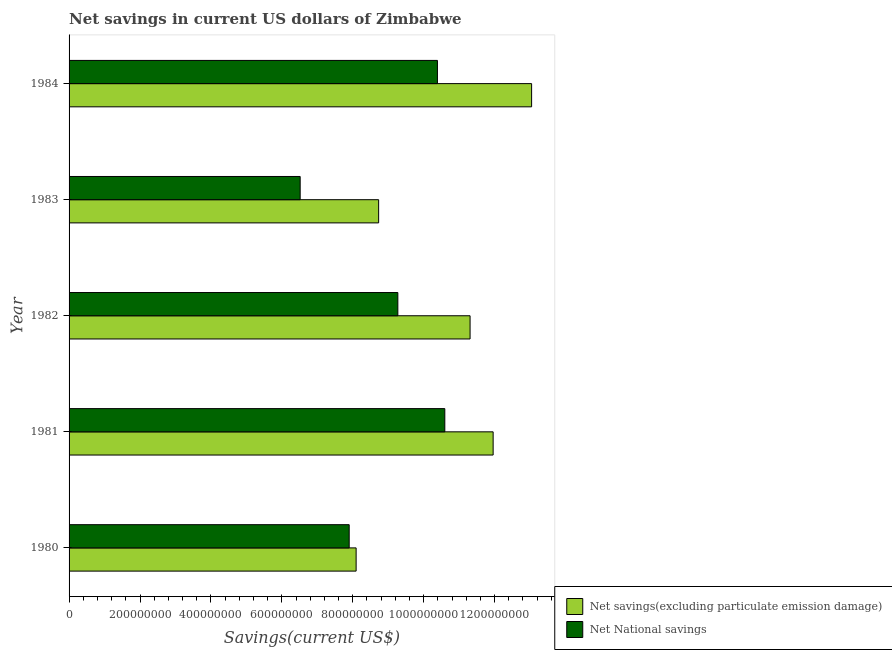How many different coloured bars are there?
Make the answer very short. 2. Are the number of bars per tick equal to the number of legend labels?
Your response must be concise. Yes. Are the number of bars on each tick of the Y-axis equal?
Make the answer very short. Yes. How many bars are there on the 4th tick from the top?
Your answer should be compact. 2. What is the label of the 1st group of bars from the top?
Offer a very short reply. 1984. In how many cases, is the number of bars for a given year not equal to the number of legend labels?
Provide a short and direct response. 0. What is the net savings(excluding particulate emission damage) in 1984?
Ensure brevity in your answer.  1.30e+09. Across all years, what is the maximum net savings(excluding particulate emission damage)?
Offer a terse response. 1.30e+09. Across all years, what is the minimum net savings(excluding particulate emission damage)?
Your answer should be very brief. 8.09e+08. In which year was the net savings(excluding particulate emission damage) maximum?
Keep it short and to the point. 1984. In which year was the net savings(excluding particulate emission damage) minimum?
Your answer should be very brief. 1980. What is the total net national savings in the graph?
Your answer should be compact. 4.47e+09. What is the difference between the net national savings in 1981 and that in 1982?
Keep it short and to the point. 1.32e+08. What is the difference between the net savings(excluding particulate emission damage) in 1984 and the net national savings in 1983?
Your response must be concise. 6.53e+08. What is the average net savings(excluding particulate emission damage) per year?
Provide a short and direct response. 1.06e+09. In the year 1980, what is the difference between the net national savings and net savings(excluding particulate emission damage)?
Keep it short and to the point. -1.95e+07. What is the ratio of the net savings(excluding particulate emission damage) in 1980 to that in 1982?
Provide a short and direct response. 0.72. Is the net savings(excluding particulate emission damage) in 1980 less than that in 1982?
Give a very brief answer. Yes. Is the difference between the net savings(excluding particulate emission damage) in 1982 and 1983 greater than the difference between the net national savings in 1982 and 1983?
Offer a very short reply. No. What is the difference between the highest and the second highest net national savings?
Provide a short and direct response. 2.08e+07. What is the difference between the highest and the lowest net savings(excluding particulate emission damage)?
Give a very brief answer. 4.95e+08. In how many years, is the net savings(excluding particulate emission damage) greater than the average net savings(excluding particulate emission damage) taken over all years?
Your answer should be very brief. 3. Is the sum of the net savings(excluding particulate emission damage) in 1981 and 1983 greater than the maximum net national savings across all years?
Make the answer very short. Yes. What does the 1st bar from the top in 1984 represents?
Offer a terse response. Net National savings. What does the 2nd bar from the bottom in 1982 represents?
Your answer should be compact. Net National savings. Are all the bars in the graph horizontal?
Give a very brief answer. Yes. What is the difference between two consecutive major ticks on the X-axis?
Give a very brief answer. 2.00e+08. Where does the legend appear in the graph?
Your answer should be very brief. Bottom right. How many legend labels are there?
Give a very brief answer. 2. What is the title of the graph?
Offer a very short reply. Net savings in current US dollars of Zimbabwe. What is the label or title of the X-axis?
Your answer should be compact. Savings(current US$). What is the Savings(current US$) in Net savings(excluding particulate emission damage) in 1980?
Give a very brief answer. 8.09e+08. What is the Savings(current US$) in Net National savings in 1980?
Offer a very short reply. 7.90e+08. What is the Savings(current US$) of Net savings(excluding particulate emission damage) in 1981?
Provide a short and direct response. 1.20e+09. What is the Savings(current US$) in Net National savings in 1981?
Your answer should be very brief. 1.06e+09. What is the Savings(current US$) of Net savings(excluding particulate emission damage) in 1982?
Provide a short and direct response. 1.13e+09. What is the Savings(current US$) in Net National savings in 1982?
Keep it short and to the point. 9.27e+08. What is the Savings(current US$) in Net savings(excluding particulate emission damage) in 1983?
Your response must be concise. 8.73e+08. What is the Savings(current US$) of Net National savings in 1983?
Your answer should be very brief. 6.52e+08. What is the Savings(current US$) in Net savings(excluding particulate emission damage) in 1984?
Give a very brief answer. 1.30e+09. What is the Savings(current US$) in Net National savings in 1984?
Provide a succinct answer. 1.04e+09. Across all years, what is the maximum Savings(current US$) of Net savings(excluding particulate emission damage)?
Make the answer very short. 1.30e+09. Across all years, what is the maximum Savings(current US$) of Net National savings?
Make the answer very short. 1.06e+09. Across all years, what is the minimum Savings(current US$) in Net savings(excluding particulate emission damage)?
Your answer should be very brief. 8.09e+08. Across all years, what is the minimum Savings(current US$) of Net National savings?
Offer a terse response. 6.52e+08. What is the total Savings(current US$) in Net savings(excluding particulate emission damage) in the graph?
Offer a very short reply. 5.31e+09. What is the total Savings(current US$) of Net National savings in the graph?
Your answer should be compact. 4.47e+09. What is the difference between the Savings(current US$) in Net savings(excluding particulate emission damage) in 1980 and that in 1981?
Make the answer very short. -3.86e+08. What is the difference between the Savings(current US$) of Net National savings in 1980 and that in 1981?
Give a very brief answer. -2.70e+08. What is the difference between the Savings(current US$) in Net savings(excluding particulate emission damage) in 1980 and that in 1982?
Offer a very short reply. -3.21e+08. What is the difference between the Savings(current US$) in Net National savings in 1980 and that in 1982?
Provide a succinct answer. -1.37e+08. What is the difference between the Savings(current US$) in Net savings(excluding particulate emission damage) in 1980 and that in 1983?
Offer a terse response. -6.35e+07. What is the difference between the Savings(current US$) in Net National savings in 1980 and that in 1983?
Offer a very short reply. 1.38e+08. What is the difference between the Savings(current US$) of Net savings(excluding particulate emission damage) in 1980 and that in 1984?
Offer a terse response. -4.95e+08. What is the difference between the Savings(current US$) of Net National savings in 1980 and that in 1984?
Ensure brevity in your answer.  -2.49e+08. What is the difference between the Savings(current US$) in Net savings(excluding particulate emission damage) in 1981 and that in 1982?
Make the answer very short. 6.50e+07. What is the difference between the Savings(current US$) of Net National savings in 1981 and that in 1982?
Offer a very short reply. 1.32e+08. What is the difference between the Savings(current US$) of Net savings(excluding particulate emission damage) in 1981 and that in 1983?
Provide a succinct answer. 3.23e+08. What is the difference between the Savings(current US$) of Net National savings in 1981 and that in 1983?
Offer a very short reply. 4.08e+08. What is the difference between the Savings(current US$) in Net savings(excluding particulate emission damage) in 1981 and that in 1984?
Give a very brief answer. -1.09e+08. What is the difference between the Savings(current US$) in Net National savings in 1981 and that in 1984?
Your answer should be very brief. 2.08e+07. What is the difference between the Savings(current US$) in Net savings(excluding particulate emission damage) in 1982 and that in 1983?
Make the answer very short. 2.58e+08. What is the difference between the Savings(current US$) of Net National savings in 1982 and that in 1983?
Your response must be concise. 2.75e+08. What is the difference between the Savings(current US$) in Net savings(excluding particulate emission damage) in 1982 and that in 1984?
Keep it short and to the point. -1.74e+08. What is the difference between the Savings(current US$) of Net National savings in 1982 and that in 1984?
Your answer should be compact. -1.12e+08. What is the difference between the Savings(current US$) in Net savings(excluding particulate emission damage) in 1983 and that in 1984?
Provide a succinct answer. -4.31e+08. What is the difference between the Savings(current US$) of Net National savings in 1983 and that in 1984?
Your answer should be compact. -3.87e+08. What is the difference between the Savings(current US$) in Net savings(excluding particulate emission damage) in 1980 and the Savings(current US$) in Net National savings in 1981?
Provide a short and direct response. -2.50e+08. What is the difference between the Savings(current US$) of Net savings(excluding particulate emission damage) in 1980 and the Savings(current US$) of Net National savings in 1982?
Give a very brief answer. -1.18e+08. What is the difference between the Savings(current US$) in Net savings(excluding particulate emission damage) in 1980 and the Savings(current US$) in Net National savings in 1983?
Give a very brief answer. 1.58e+08. What is the difference between the Savings(current US$) in Net savings(excluding particulate emission damage) in 1980 and the Savings(current US$) in Net National savings in 1984?
Keep it short and to the point. -2.29e+08. What is the difference between the Savings(current US$) in Net savings(excluding particulate emission damage) in 1981 and the Savings(current US$) in Net National savings in 1982?
Provide a succinct answer. 2.69e+08. What is the difference between the Savings(current US$) in Net savings(excluding particulate emission damage) in 1981 and the Savings(current US$) in Net National savings in 1983?
Your answer should be very brief. 5.44e+08. What is the difference between the Savings(current US$) in Net savings(excluding particulate emission damage) in 1981 and the Savings(current US$) in Net National savings in 1984?
Keep it short and to the point. 1.57e+08. What is the difference between the Savings(current US$) in Net savings(excluding particulate emission damage) in 1982 and the Savings(current US$) in Net National savings in 1983?
Make the answer very short. 4.79e+08. What is the difference between the Savings(current US$) in Net savings(excluding particulate emission damage) in 1982 and the Savings(current US$) in Net National savings in 1984?
Provide a short and direct response. 9.20e+07. What is the difference between the Savings(current US$) of Net savings(excluding particulate emission damage) in 1983 and the Savings(current US$) of Net National savings in 1984?
Make the answer very short. -1.66e+08. What is the average Savings(current US$) in Net savings(excluding particulate emission damage) per year?
Your answer should be compact. 1.06e+09. What is the average Savings(current US$) in Net National savings per year?
Keep it short and to the point. 8.93e+08. In the year 1980, what is the difference between the Savings(current US$) of Net savings(excluding particulate emission damage) and Savings(current US$) of Net National savings?
Ensure brevity in your answer.  1.95e+07. In the year 1981, what is the difference between the Savings(current US$) of Net savings(excluding particulate emission damage) and Savings(current US$) of Net National savings?
Your answer should be very brief. 1.36e+08. In the year 1982, what is the difference between the Savings(current US$) of Net savings(excluding particulate emission damage) and Savings(current US$) of Net National savings?
Your answer should be very brief. 2.04e+08. In the year 1983, what is the difference between the Savings(current US$) of Net savings(excluding particulate emission damage) and Savings(current US$) of Net National savings?
Provide a short and direct response. 2.21e+08. In the year 1984, what is the difference between the Savings(current US$) of Net savings(excluding particulate emission damage) and Savings(current US$) of Net National savings?
Give a very brief answer. 2.66e+08. What is the ratio of the Savings(current US$) in Net savings(excluding particulate emission damage) in 1980 to that in 1981?
Offer a very short reply. 0.68. What is the ratio of the Savings(current US$) in Net National savings in 1980 to that in 1981?
Your answer should be compact. 0.75. What is the ratio of the Savings(current US$) in Net savings(excluding particulate emission damage) in 1980 to that in 1982?
Provide a succinct answer. 0.72. What is the ratio of the Savings(current US$) in Net National savings in 1980 to that in 1982?
Your response must be concise. 0.85. What is the ratio of the Savings(current US$) in Net savings(excluding particulate emission damage) in 1980 to that in 1983?
Your response must be concise. 0.93. What is the ratio of the Savings(current US$) of Net National savings in 1980 to that in 1983?
Provide a succinct answer. 1.21. What is the ratio of the Savings(current US$) of Net savings(excluding particulate emission damage) in 1980 to that in 1984?
Your answer should be very brief. 0.62. What is the ratio of the Savings(current US$) in Net National savings in 1980 to that in 1984?
Your answer should be compact. 0.76. What is the ratio of the Savings(current US$) in Net savings(excluding particulate emission damage) in 1981 to that in 1982?
Provide a succinct answer. 1.06. What is the ratio of the Savings(current US$) in Net National savings in 1981 to that in 1982?
Offer a very short reply. 1.14. What is the ratio of the Savings(current US$) of Net savings(excluding particulate emission damage) in 1981 to that in 1983?
Give a very brief answer. 1.37. What is the ratio of the Savings(current US$) of Net National savings in 1981 to that in 1983?
Offer a terse response. 1.63. What is the ratio of the Savings(current US$) in Net savings(excluding particulate emission damage) in 1981 to that in 1984?
Give a very brief answer. 0.92. What is the ratio of the Savings(current US$) of Net National savings in 1981 to that in 1984?
Ensure brevity in your answer.  1.02. What is the ratio of the Savings(current US$) in Net savings(excluding particulate emission damage) in 1982 to that in 1983?
Provide a short and direct response. 1.3. What is the ratio of the Savings(current US$) in Net National savings in 1982 to that in 1983?
Ensure brevity in your answer.  1.42. What is the ratio of the Savings(current US$) of Net savings(excluding particulate emission damage) in 1982 to that in 1984?
Your answer should be compact. 0.87. What is the ratio of the Savings(current US$) of Net National savings in 1982 to that in 1984?
Provide a succinct answer. 0.89. What is the ratio of the Savings(current US$) of Net savings(excluding particulate emission damage) in 1983 to that in 1984?
Your answer should be very brief. 0.67. What is the ratio of the Savings(current US$) of Net National savings in 1983 to that in 1984?
Provide a succinct answer. 0.63. What is the difference between the highest and the second highest Savings(current US$) of Net savings(excluding particulate emission damage)?
Make the answer very short. 1.09e+08. What is the difference between the highest and the second highest Savings(current US$) in Net National savings?
Make the answer very short. 2.08e+07. What is the difference between the highest and the lowest Savings(current US$) of Net savings(excluding particulate emission damage)?
Offer a terse response. 4.95e+08. What is the difference between the highest and the lowest Savings(current US$) of Net National savings?
Your answer should be very brief. 4.08e+08. 